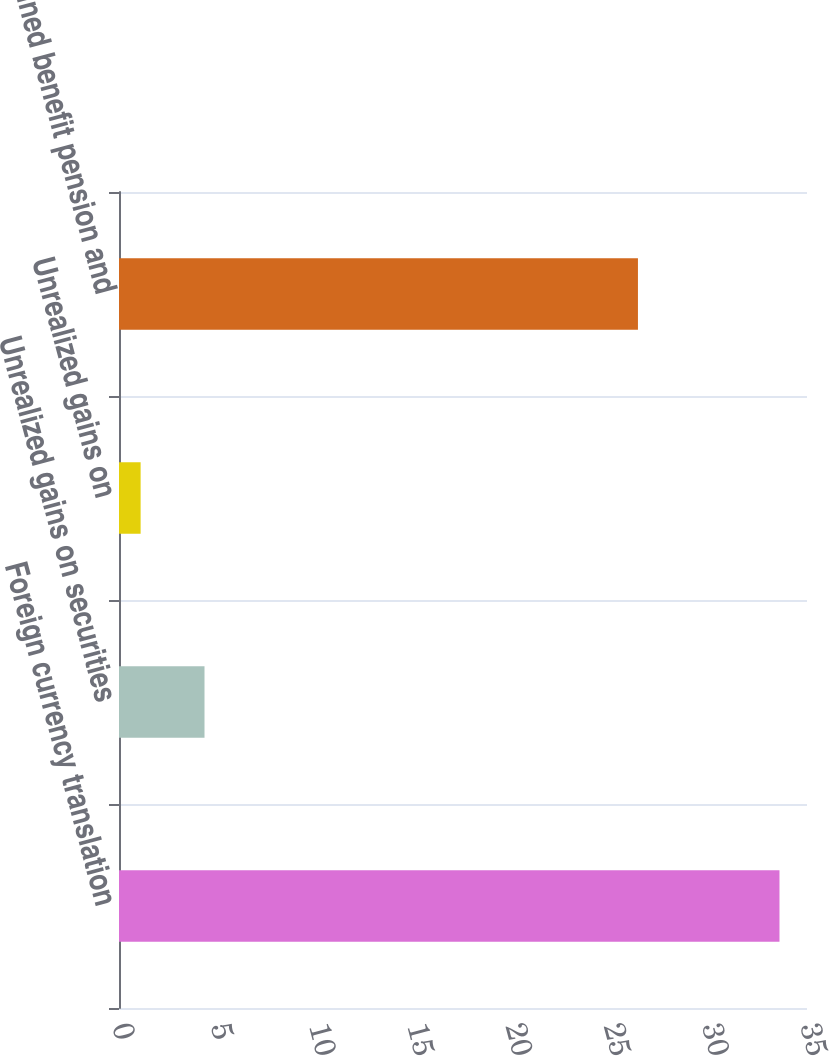<chart> <loc_0><loc_0><loc_500><loc_500><bar_chart><fcel>Foreign currency translation<fcel>Unrealized gains on securities<fcel>Unrealized gains on<fcel>Defined benefit pension and<nl><fcel>33.6<fcel>4.35<fcel>1.1<fcel>26.4<nl></chart> 